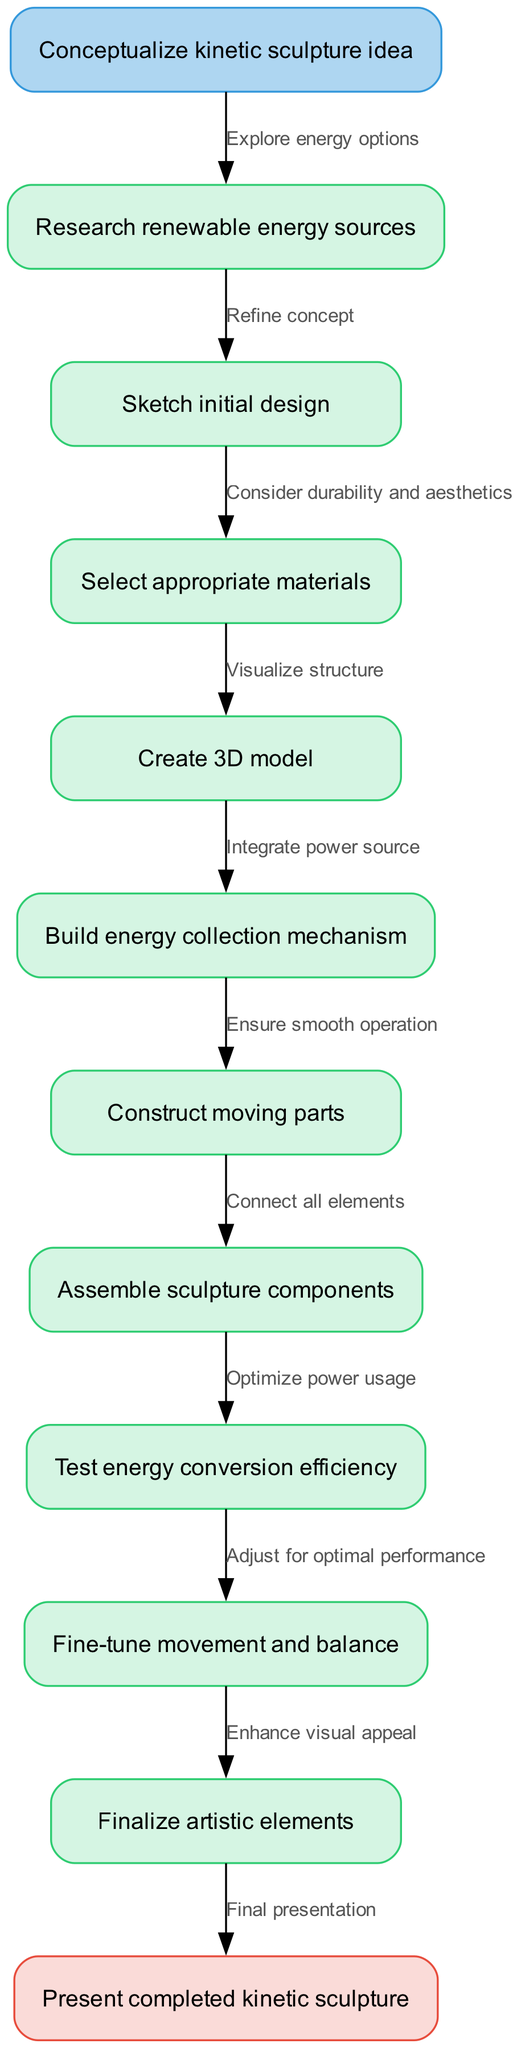What is the starting point of the diagram? The starting point is explicitly labeled as "Conceptualize kinetic sculpture idea," indicating the initial phase of the process depicted in the flowchart.
Answer: Conceptualize kinetic sculpture idea What is the last step before completion? The last step before reaching the end node is "Finalize artistic elements," which denotes the finalization process just before the presentation.
Answer: Finalize artistic elements How many nodes are in the diagram? The diagram lists a total of 11 nodes: 1 start node, 9 process nodes, and 1 end node, thus totaling to 11.
Answer: 11 What is the relationship between "Sketch initial design" and "Select appropriate materials"? "Sketch initial design" leads to "Select appropriate materials," as each node is connected sequentially, indicating that selecting materials follows the sketching phase.
Answer: Select appropriate materials What is the role of "Test energy conversion efficiency"? "Test energy conversion efficiency" acts as a crucial process step where the efficiency of the kinetic sculpture's energy utilization is evaluated to ensure optimal performance later on.
Answer: Evaluate efficiency What happens after "Create 3D model"? After "Create 3D model," the next step is "Build energy collection mechanism," which indicates a progression from modeling to practical construction focused on energy collection.
Answer: Build energy collection mechanism Which node involves ensuring durability and aesthetics? The node "Select appropriate materials" focuses on considering aspects of durability and aesthetics in relation to the materials chosen for the kinetic sculpture.
Answer: Select appropriate materials How many edges connect the nodes in this flowchart? There are 10 edges in total because each of the 9 process nodes connects with the subsequent node and the start node connects to the first process node.
Answer: 10 What is the significance of "Optimize power usage"? "Optimize power usage" is essential for maximizing the efficiency of the sculpture's energy system, ensuring that it operates effectively while utilizing renewable energy resources.
Answer: Maximize efficiency 